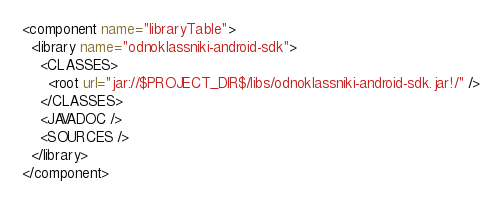Convert code to text. <code><loc_0><loc_0><loc_500><loc_500><_XML_><component name="libraryTable">
  <library name="odnoklassniki-android-sdk">
    <CLASSES>
      <root url="jar://$PROJECT_DIR$/libs/odnoklassniki-android-sdk.jar!/" />
    </CLASSES>
    <JAVADOC />
    <SOURCES />
  </library>
</component></code> 